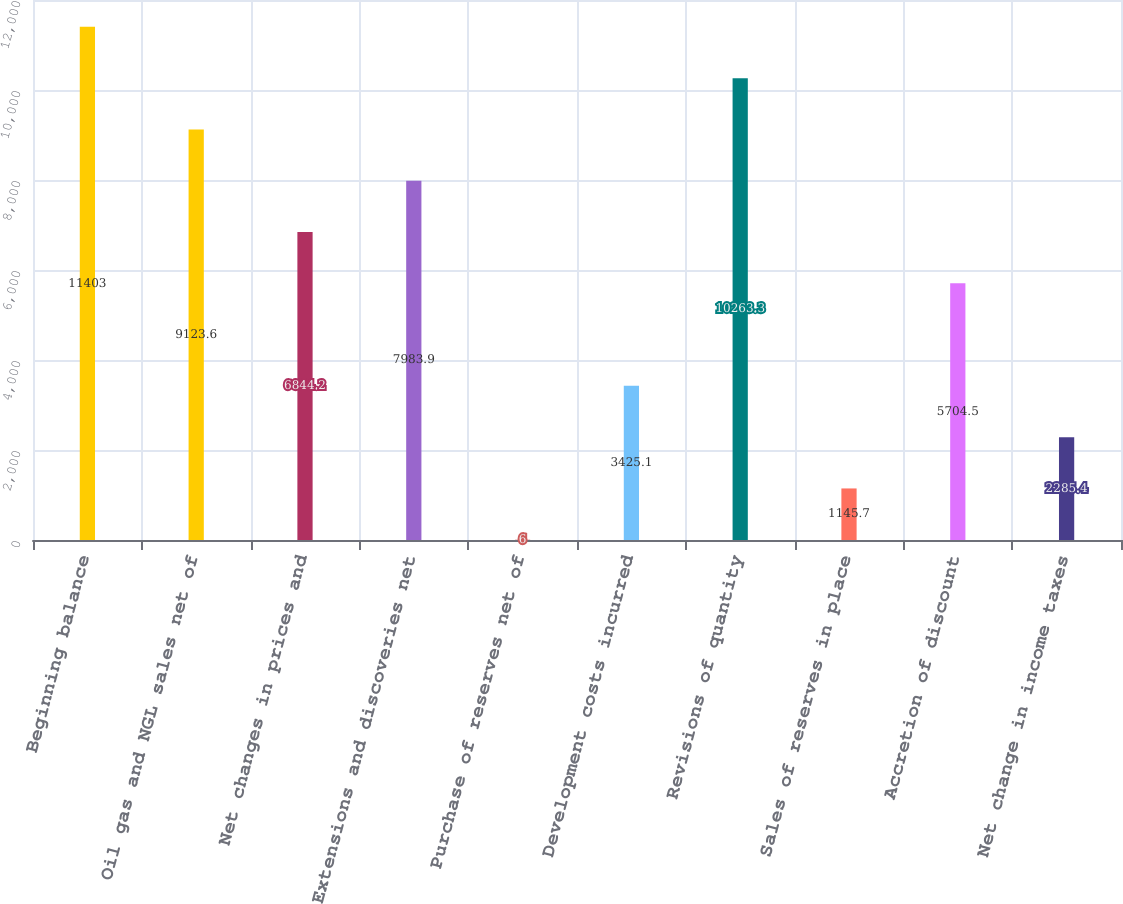<chart> <loc_0><loc_0><loc_500><loc_500><bar_chart><fcel>Beginning balance<fcel>Oil gas and NGL sales net of<fcel>Net changes in prices and<fcel>Extensions and discoveries net<fcel>Purchase of reserves net of<fcel>Development costs incurred<fcel>Revisions of quantity<fcel>Sales of reserves in place<fcel>Accretion of discount<fcel>Net change in income taxes<nl><fcel>11403<fcel>9123.6<fcel>6844.2<fcel>7983.9<fcel>6<fcel>3425.1<fcel>10263.3<fcel>1145.7<fcel>5704.5<fcel>2285.4<nl></chart> 